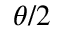<formula> <loc_0><loc_0><loc_500><loc_500>\theta / 2</formula> 